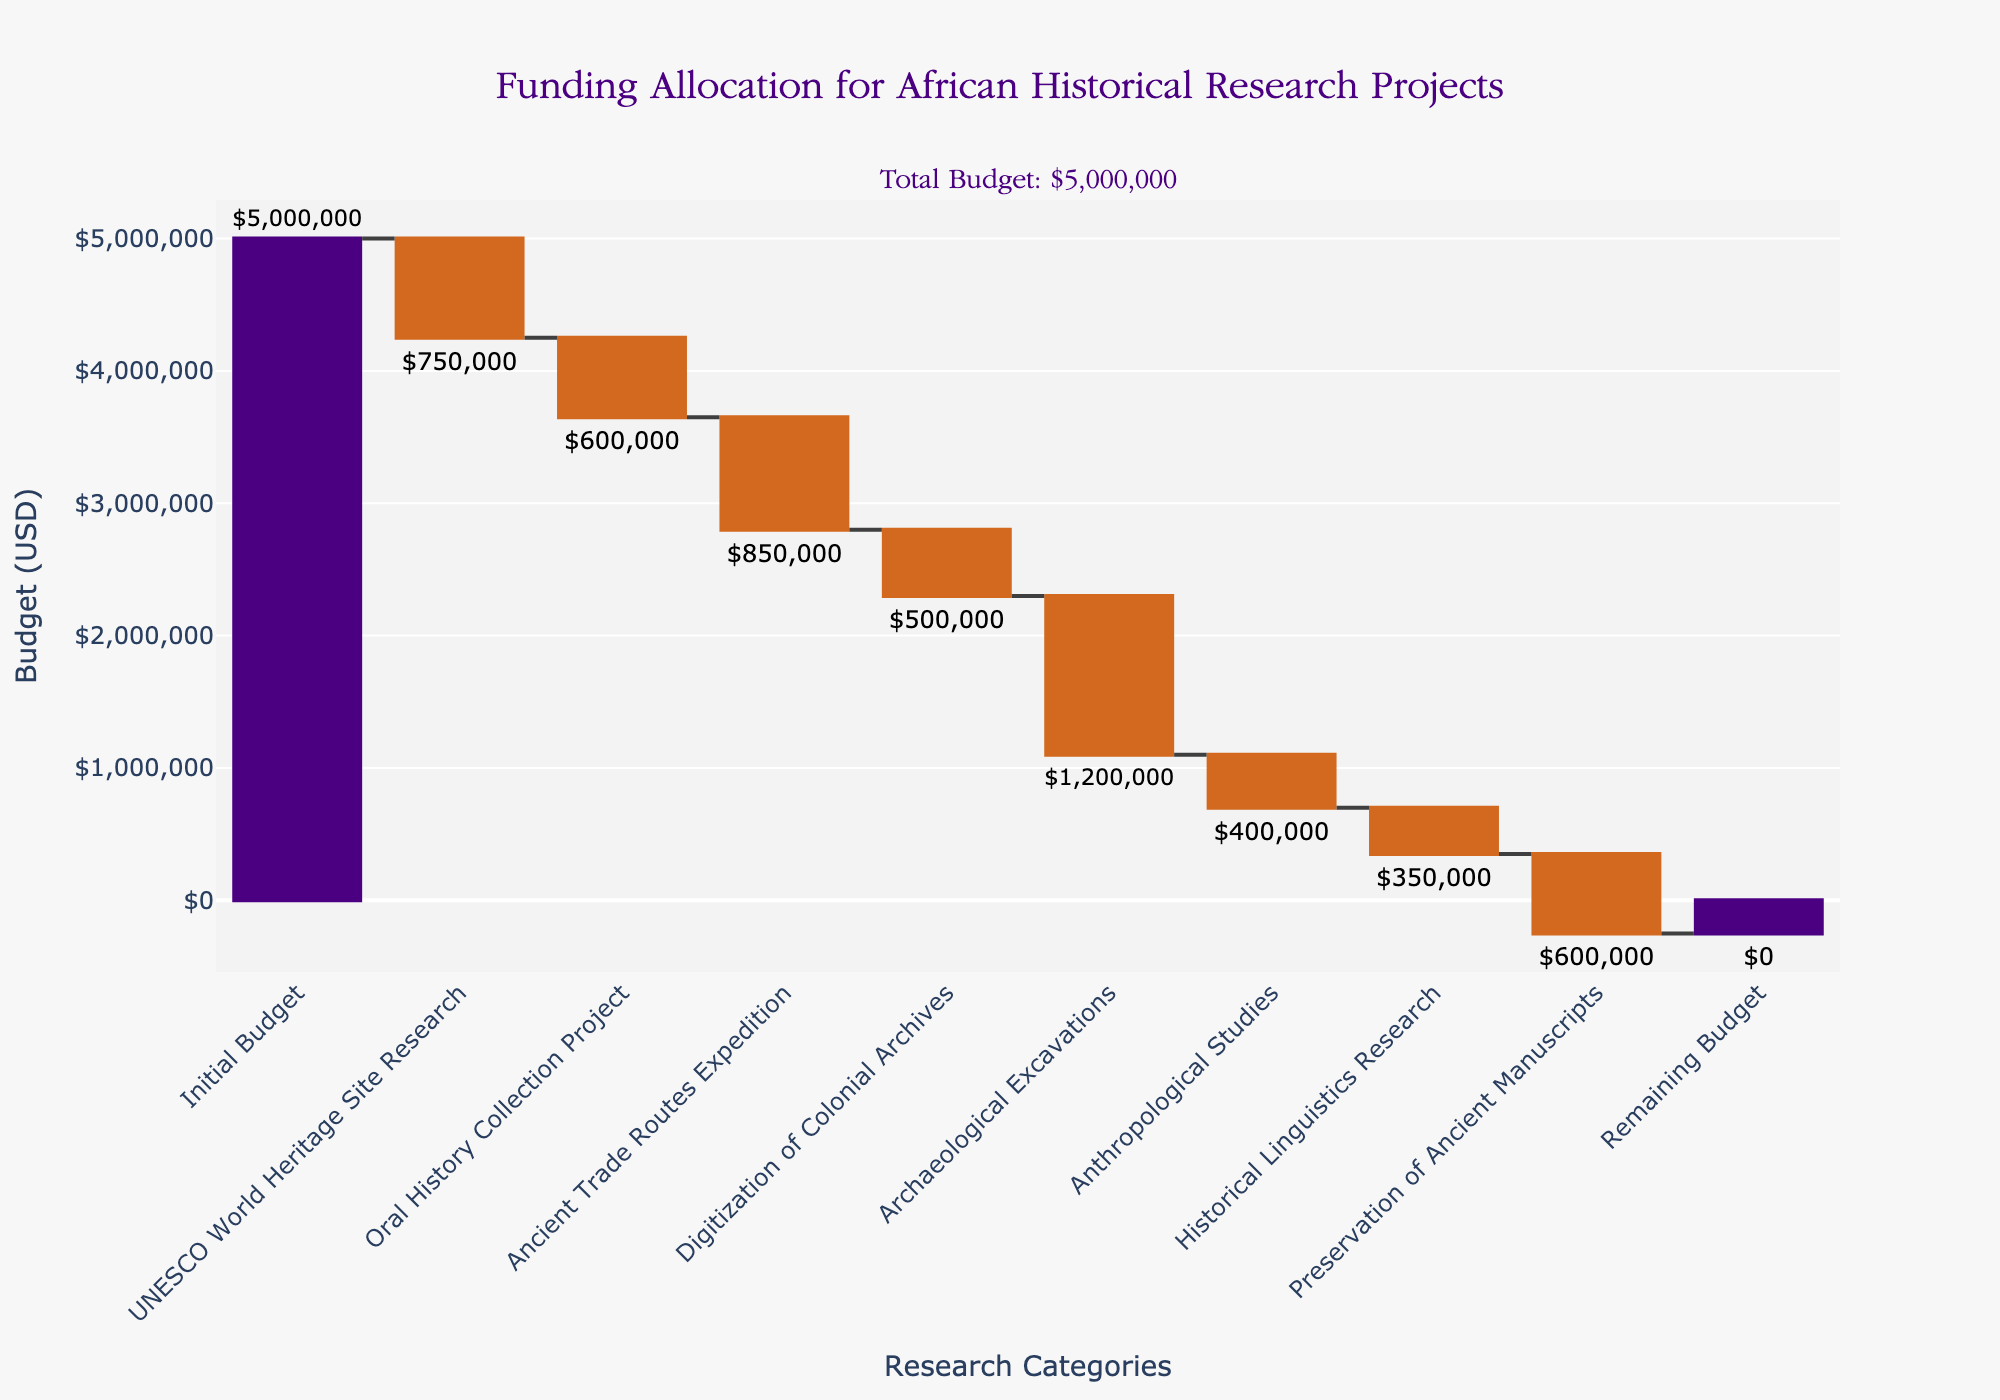What is the title of the chart? The title of the chart is located at the top of the figure. It reads "Funding Allocation for African Historical Research Projects".
Answer: Funding Allocation for African Historical Research Projects What is the total initial budget allocated for the research projects? The initial budget is the first data point on the chart, marked under the "Initial Budget" category. The budget is displayed as $5,000,000.
Answer: $5,000,000 How much budget was allocated to the Oral History Collection Project? The budget for the Oral History Collection Project is shown as a bar labeled "Oral History Collection Project", with the amount displayed as $600,000.
Answer: $600,000 Which research project received the highest amount of funding? Look for the longest bar among the projects. The "Archaeological Excavations" has the highest value, marked at $1,200,000.
Answer: Archaeological Excavations What is the remaining budget after all the allocations? The "Remaining Budget" value is depicted at the end of the chart. It is labeled as $0.
Answer: $0 How much was allocated to Historical Linguistics Research and Preservation of Ancient Manuscripts combined? Add the values for both categories: Historical Linguistics Research ($350,000) + Preservation of Ancient Manuscripts ($600,000) = $950,000.
Answer: $950,000 Is the budget allocation for the Digitization of Colonial Archives greater than or less than that for Anthropological Studies? Compare the values shown on the chart: Digitization of Colonial Archives ($500,000) and Anthropological Studies ($400,000). $500,000 is greater than $400,000.
Answer: Greater than What is the total amount allocated across all research projects excluding the remaining budget? Sum the values for all the projects: $750,000 (UNESCO World Heritage Site Research) + $600,000 (Oral History Collection Project) + $850,000 (Ancient Trade Routes Expedition) + $500,000 (Digitization of Colonial Archives) + $1,200,000 (Archaeological Excavations) + $400,000 (Anthropological Studies) + $350,000 (Historical Linguistics Research) + $600,000 (Preservation of Ancient Manuscripts) = $5,250,000. This indicates an initial budget shortfall.
Answer: $5,250,000 